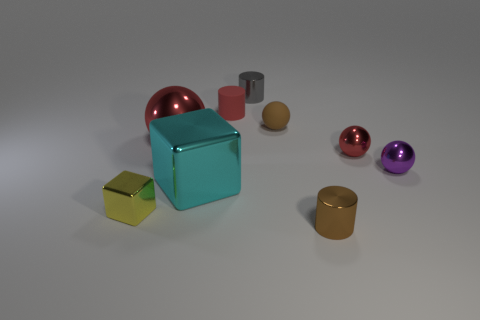Subtract all cubes. How many objects are left? 7 Subtract all cyan blocks. How many blocks are left? 1 Subtract all purple metal spheres. How many spheres are left? 3 Subtract 0 gray cubes. How many objects are left? 9 Subtract 2 cylinders. How many cylinders are left? 1 Subtract all yellow balls. Subtract all purple cylinders. How many balls are left? 4 Subtract all brown balls. How many brown cylinders are left? 1 Subtract all small yellow shiny cubes. Subtract all brown objects. How many objects are left? 6 Add 2 rubber spheres. How many rubber spheres are left? 3 Add 1 small rubber blocks. How many small rubber blocks exist? 1 